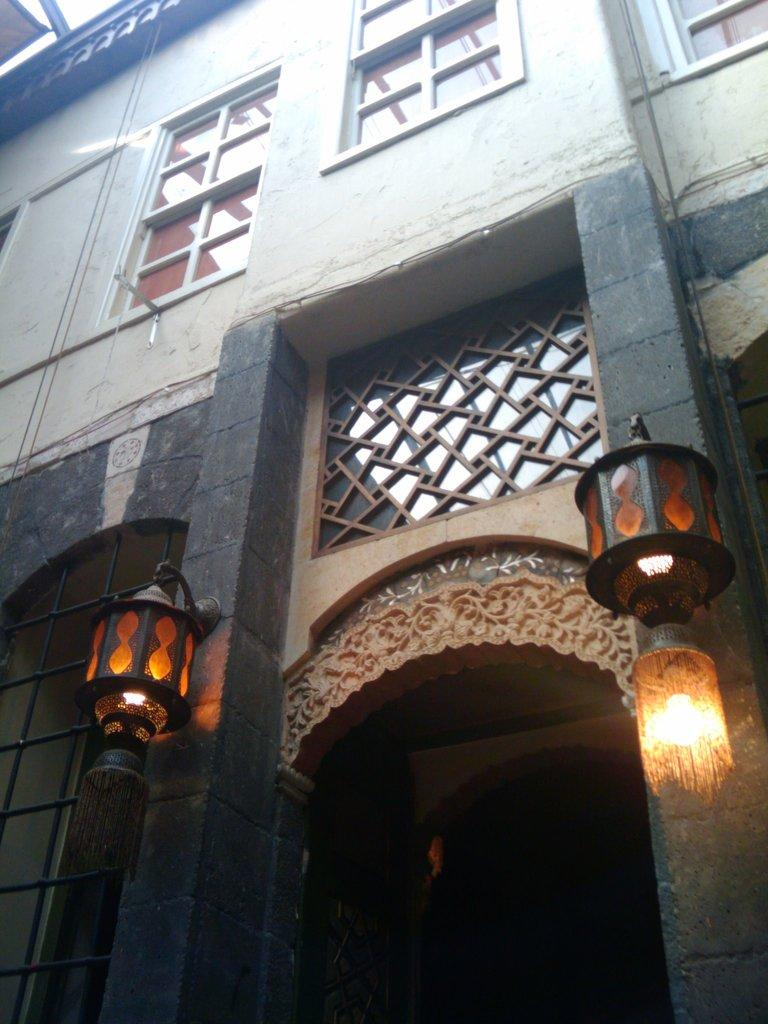What is the main subject of the image? The main subject of the image is a building. Can you describe any specific features of the building? Yes, there are two lamps hanging on the wall of the building. How many gloves can be seen hanging on the lamps in the image? There are no gloves present in the image; it only features a building with two lamps hanging on the wall. What type of park is visible in the background of the image? There is no park visible in the image; it only features a building with two lamps hanging on the wall. 